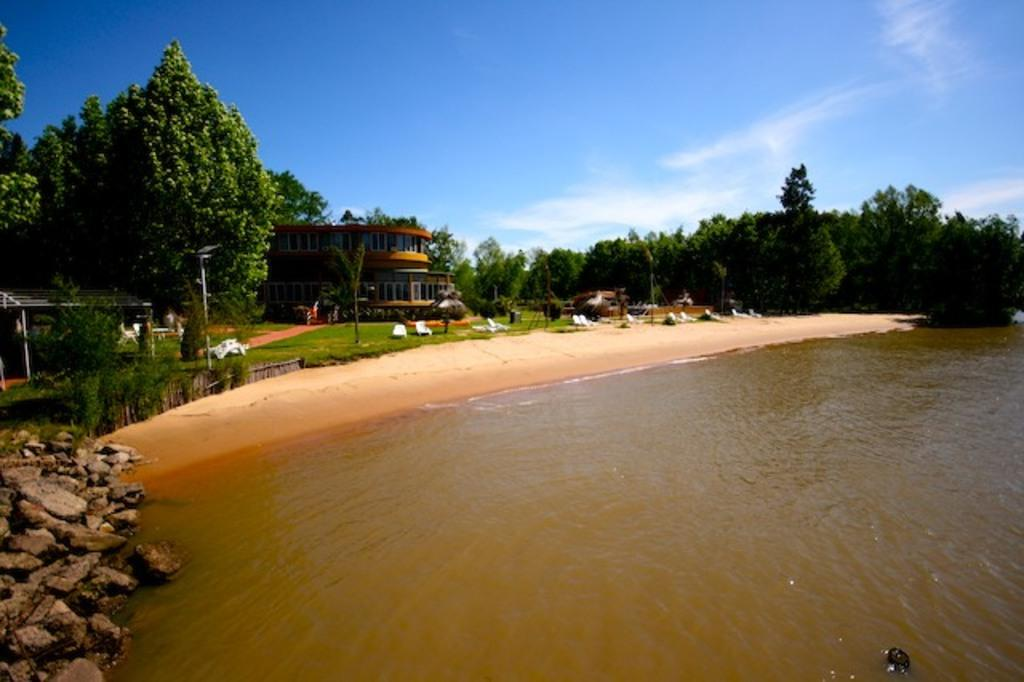What type of natural elements can be seen in the image? There are trees in the image. What type of man-made structures are present in the image? There are buildings in the image. What type of furniture is visible in the image? There are chairs in the image. What type of vertical structures are present in the image? There are poles in the image. What type of geological feature is on the left side of the image? There are rocks on the left side of the image. What type of liquid is present at the bottom of the image? There is water at the bottom of the image. How many sisters are sitting on the chairs in the image? There is no mention of sisters or anyone sitting on the chairs in the image. What type of drink is being poured from the poles in the image? There are no drinks or any indication of pouring in the image. What phase of the moon is visible in the image? There is no moon visible in the image. 